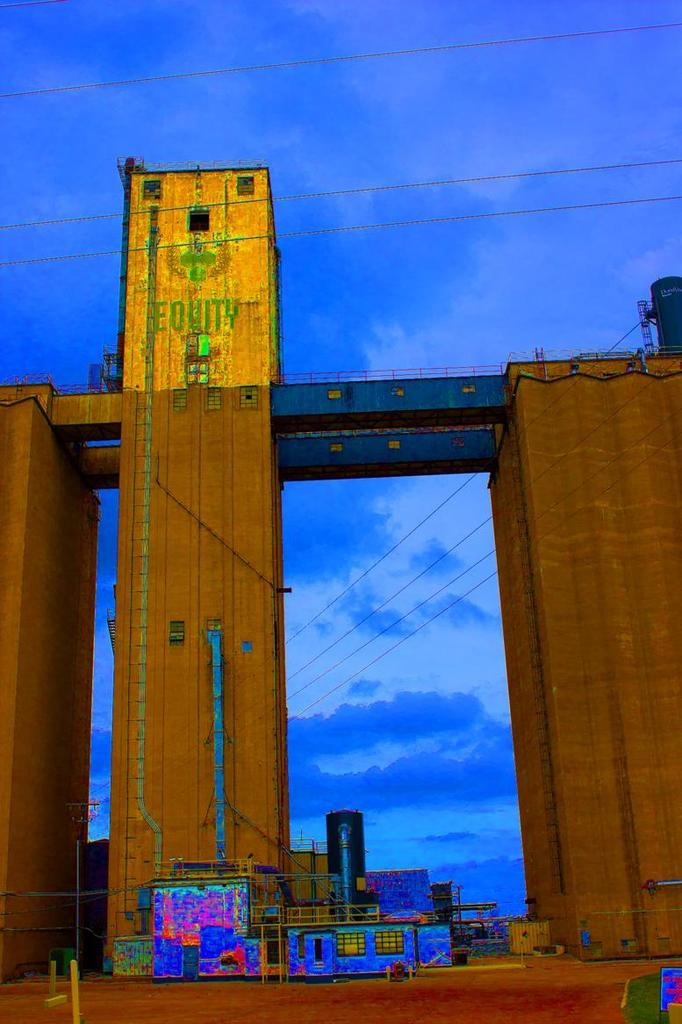What type of structure is visible in the image? There is an architecture in the image. What can be seen in the sky in the image? A: There are clouds in the sky in the image. What type of card is being used to control the current in the image? There is no card or current present in the image; it only features an architecture and clouds in the sky. 